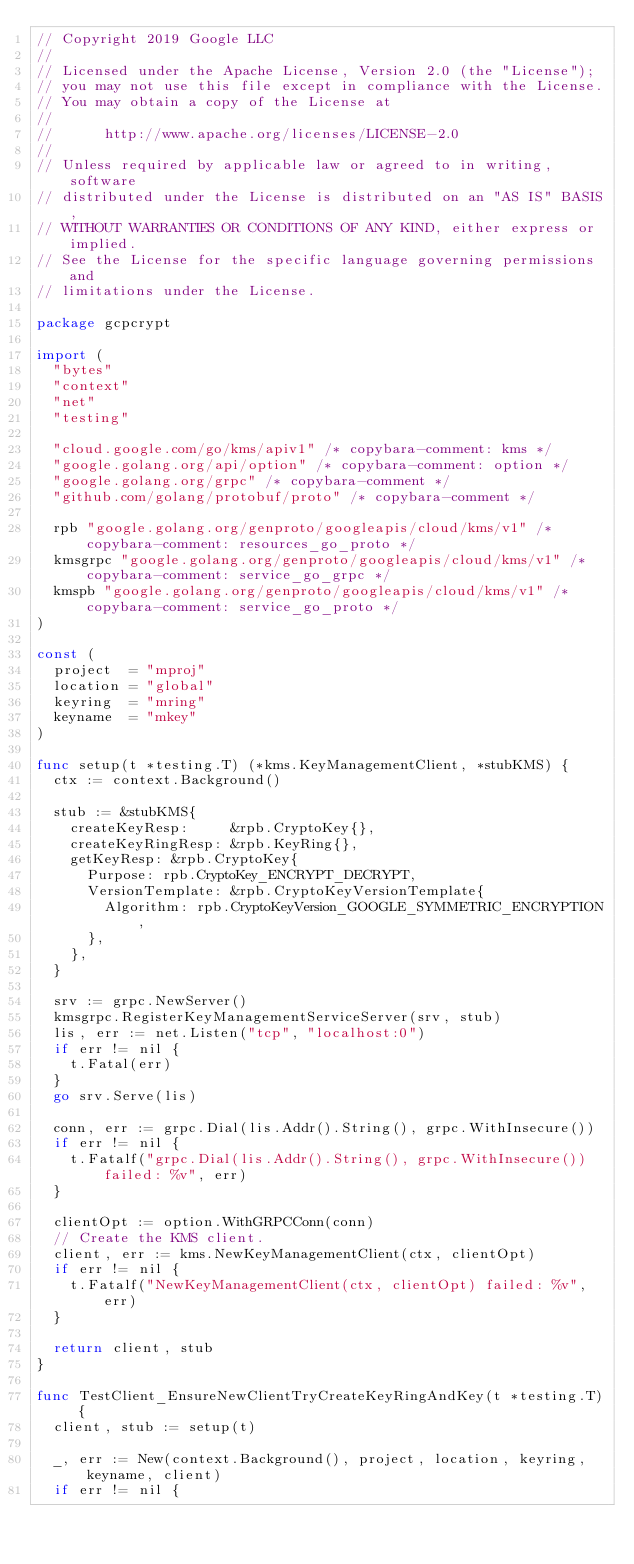Convert code to text. <code><loc_0><loc_0><loc_500><loc_500><_Go_>// Copyright 2019 Google LLC
//
// Licensed under the Apache License, Version 2.0 (the "License");
// you may not use this file except in compliance with the License.
// You may obtain a copy of the License at
//
//      http://www.apache.org/licenses/LICENSE-2.0
//
// Unless required by applicable law or agreed to in writing, software
// distributed under the License is distributed on an "AS IS" BASIS,
// WITHOUT WARRANTIES OR CONDITIONS OF ANY KIND, either express or implied.
// See the License for the specific language governing permissions and
// limitations under the License.

package gcpcrypt

import (
	"bytes"
	"context"
	"net"
	"testing"

	"cloud.google.com/go/kms/apiv1" /* copybara-comment: kms */
	"google.golang.org/api/option" /* copybara-comment: option */
	"google.golang.org/grpc" /* copybara-comment */
	"github.com/golang/protobuf/proto" /* copybara-comment */

	rpb "google.golang.org/genproto/googleapis/cloud/kms/v1" /* copybara-comment: resources_go_proto */
	kmsgrpc "google.golang.org/genproto/googleapis/cloud/kms/v1" /* copybara-comment: service_go_grpc */
	kmspb "google.golang.org/genproto/googleapis/cloud/kms/v1" /* copybara-comment: service_go_proto */
)

const (
	project  = "mproj"
	location = "global"
	keyring  = "mring"
	keyname  = "mkey"
)

func setup(t *testing.T) (*kms.KeyManagementClient, *stubKMS) {
	ctx := context.Background()

	stub := &stubKMS{
		createKeyResp:     &rpb.CryptoKey{},
		createKeyRingResp: &rpb.KeyRing{},
		getKeyResp: &rpb.CryptoKey{
			Purpose: rpb.CryptoKey_ENCRYPT_DECRYPT,
			VersionTemplate: &rpb.CryptoKeyVersionTemplate{
				Algorithm: rpb.CryptoKeyVersion_GOOGLE_SYMMETRIC_ENCRYPTION,
			},
		},
	}

	srv := grpc.NewServer()
	kmsgrpc.RegisterKeyManagementServiceServer(srv, stub)
	lis, err := net.Listen("tcp", "localhost:0")
	if err != nil {
		t.Fatal(err)
	}
	go srv.Serve(lis)

	conn, err := grpc.Dial(lis.Addr().String(), grpc.WithInsecure())
	if err != nil {
		t.Fatalf("grpc.Dial(lis.Addr().String(), grpc.WithInsecure()) failed: %v", err)
	}

	clientOpt := option.WithGRPCConn(conn)
	// Create the KMS client.
	client, err := kms.NewKeyManagementClient(ctx, clientOpt)
	if err != nil {
		t.Fatalf("NewKeyManagementClient(ctx, clientOpt) failed: %v", err)
	}

	return client, stub
}

func TestClient_EnsureNewClientTryCreateKeyRingAndKey(t *testing.T) {
	client, stub := setup(t)

	_, err := New(context.Background(), project, location, keyring, keyname, client)
	if err != nil {</code> 